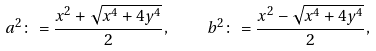<formula> <loc_0><loc_0><loc_500><loc_500>a ^ { 2 } \colon = \frac { x ^ { 2 } + \sqrt { x ^ { 4 } + 4 y ^ { 4 } } } { 2 } , \quad b ^ { 2 } \colon = \frac { x ^ { 2 } - \sqrt { x ^ { 4 } + 4 y ^ { 4 } } } { 2 } ,</formula> 